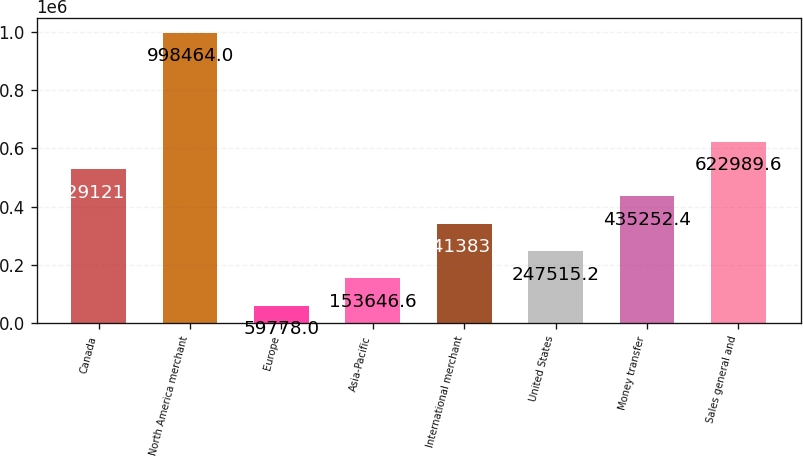<chart> <loc_0><loc_0><loc_500><loc_500><bar_chart><fcel>Canada<fcel>North America merchant<fcel>Europe<fcel>Asia-Pacific<fcel>International merchant<fcel>United States<fcel>Money transfer<fcel>Sales general and<nl><fcel>529121<fcel>998464<fcel>59778<fcel>153647<fcel>341384<fcel>247515<fcel>435252<fcel>622990<nl></chart> 